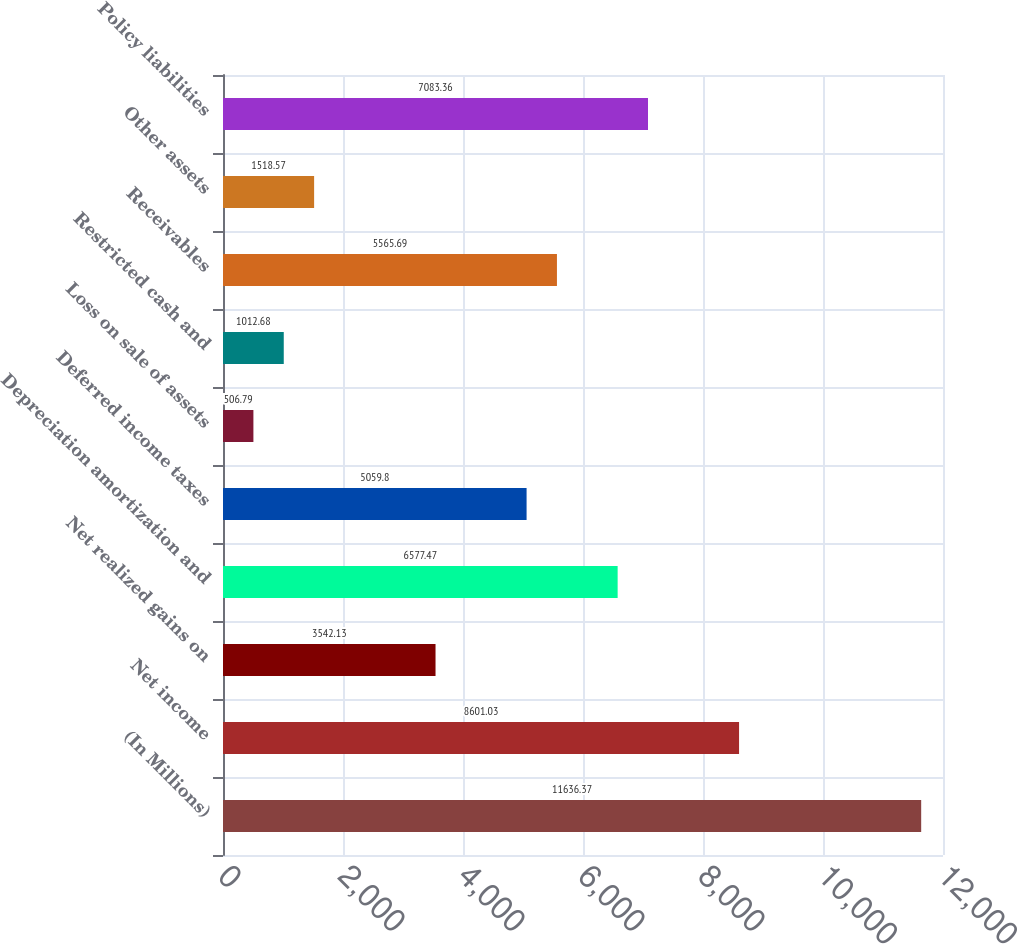<chart> <loc_0><loc_0><loc_500><loc_500><bar_chart><fcel>(In Millions)<fcel>Net income<fcel>Net realized gains on<fcel>Depreciation amortization and<fcel>Deferred income taxes<fcel>Loss on sale of assets<fcel>Restricted cash and<fcel>Receivables<fcel>Other assets<fcel>Policy liabilities<nl><fcel>11636.4<fcel>8601.03<fcel>3542.13<fcel>6577.47<fcel>5059.8<fcel>506.79<fcel>1012.68<fcel>5565.69<fcel>1518.57<fcel>7083.36<nl></chart> 